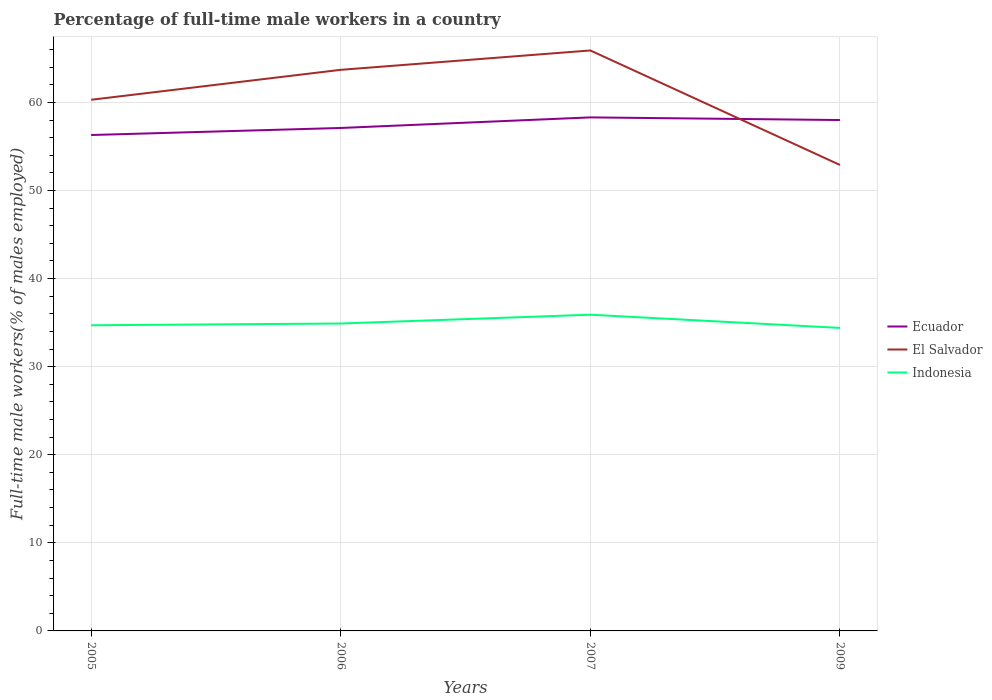How many different coloured lines are there?
Your answer should be compact. 3. Across all years, what is the maximum percentage of full-time male workers in Indonesia?
Offer a very short reply. 34.4. What is the total percentage of full-time male workers in Ecuador in the graph?
Your answer should be very brief. -0.9. What is the difference between the highest and the lowest percentage of full-time male workers in Ecuador?
Ensure brevity in your answer.  2. How many years are there in the graph?
Provide a succinct answer. 4. What is the difference between two consecutive major ticks on the Y-axis?
Your answer should be very brief. 10. Does the graph contain any zero values?
Keep it short and to the point. No. How many legend labels are there?
Provide a short and direct response. 3. How are the legend labels stacked?
Give a very brief answer. Vertical. What is the title of the graph?
Offer a terse response. Percentage of full-time male workers in a country. What is the label or title of the Y-axis?
Your answer should be very brief. Full-time male workers(% of males employed). What is the Full-time male workers(% of males employed) in Ecuador in 2005?
Provide a short and direct response. 56.3. What is the Full-time male workers(% of males employed) of El Salvador in 2005?
Your answer should be very brief. 60.3. What is the Full-time male workers(% of males employed) in Indonesia in 2005?
Keep it short and to the point. 34.7. What is the Full-time male workers(% of males employed) of Ecuador in 2006?
Provide a succinct answer. 57.1. What is the Full-time male workers(% of males employed) in El Salvador in 2006?
Your answer should be very brief. 63.7. What is the Full-time male workers(% of males employed) of Indonesia in 2006?
Provide a short and direct response. 34.9. What is the Full-time male workers(% of males employed) of Ecuador in 2007?
Your response must be concise. 58.3. What is the Full-time male workers(% of males employed) in El Salvador in 2007?
Offer a terse response. 65.9. What is the Full-time male workers(% of males employed) in Indonesia in 2007?
Your answer should be very brief. 35.9. What is the Full-time male workers(% of males employed) of El Salvador in 2009?
Make the answer very short. 52.9. What is the Full-time male workers(% of males employed) in Indonesia in 2009?
Keep it short and to the point. 34.4. Across all years, what is the maximum Full-time male workers(% of males employed) in Ecuador?
Provide a short and direct response. 58.3. Across all years, what is the maximum Full-time male workers(% of males employed) of El Salvador?
Give a very brief answer. 65.9. Across all years, what is the maximum Full-time male workers(% of males employed) in Indonesia?
Keep it short and to the point. 35.9. Across all years, what is the minimum Full-time male workers(% of males employed) of Ecuador?
Your answer should be very brief. 56.3. Across all years, what is the minimum Full-time male workers(% of males employed) of El Salvador?
Ensure brevity in your answer.  52.9. Across all years, what is the minimum Full-time male workers(% of males employed) of Indonesia?
Your answer should be very brief. 34.4. What is the total Full-time male workers(% of males employed) in Ecuador in the graph?
Ensure brevity in your answer.  229.7. What is the total Full-time male workers(% of males employed) in El Salvador in the graph?
Keep it short and to the point. 242.8. What is the total Full-time male workers(% of males employed) of Indonesia in the graph?
Make the answer very short. 139.9. What is the difference between the Full-time male workers(% of males employed) of Ecuador in 2005 and that in 2006?
Offer a very short reply. -0.8. What is the difference between the Full-time male workers(% of males employed) of El Salvador in 2005 and that in 2006?
Keep it short and to the point. -3.4. What is the difference between the Full-time male workers(% of males employed) in Ecuador in 2005 and that in 2007?
Your answer should be compact. -2. What is the difference between the Full-time male workers(% of males employed) of El Salvador in 2005 and that in 2007?
Ensure brevity in your answer.  -5.6. What is the difference between the Full-time male workers(% of males employed) in Indonesia in 2005 and that in 2007?
Your answer should be very brief. -1.2. What is the difference between the Full-time male workers(% of males employed) in Ecuador in 2005 and that in 2009?
Provide a succinct answer. -1.7. What is the difference between the Full-time male workers(% of males employed) of El Salvador in 2005 and that in 2009?
Provide a succinct answer. 7.4. What is the difference between the Full-time male workers(% of males employed) of El Salvador in 2006 and that in 2007?
Provide a short and direct response. -2.2. What is the difference between the Full-time male workers(% of males employed) of Indonesia in 2006 and that in 2007?
Give a very brief answer. -1. What is the difference between the Full-time male workers(% of males employed) of Ecuador in 2006 and that in 2009?
Provide a short and direct response. -0.9. What is the difference between the Full-time male workers(% of males employed) in El Salvador in 2006 and that in 2009?
Provide a succinct answer. 10.8. What is the difference between the Full-time male workers(% of males employed) of Indonesia in 2006 and that in 2009?
Give a very brief answer. 0.5. What is the difference between the Full-time male workers(% of males employed) in Ecuador in 2007 and that in 2009?
Your answer should be very brief. 0.3. What is the difference between the Full-time male workers(% of males employed) of El Salvador in 2007 and that in 2009?
Offer a terse response. 13. What is the difference between the Full-time male workers(% of males employed) in Indonesia in 2007 and that in 2009?
Provide a succinct answer. 1.5. What is the difference between the Full-time male workers(% of males employed) in Ecuador in 2005 and the Full-time male workers(% of males employed) in El Salvador in 2006?
Ensure brevity in your answer.  -7.4. What is the difference between the Full-time male workers(% of males employed) of Ecuador in 2005 and the Full-time male workers(% of males employed) of Indonesia in 2006?
Make the answer very short. 21.4. What is the difference between the Full-time male workers(% of males employed) in El Salvador in 2005 and the Full-time male workers(% of males employed) in Indonesia in 2006?
Your answer should be very brief. 25.4. What is the difference between the Full-time male workers(% of males employed) of Ecuador in 2005 and the Full-time male workers(% of males employed) of Indonesia in 2007?
Offer a very short reply. 20.4. What is the difference between the Full-time male workers(% of males employed) of El Salvador in 2005 and the Full-time male workers(% of males employed) of Indonesia in 2007?
Offer a terse response. 24.4. What is the difference between the Full-time male workers(% of males employed) in Ecuador in 2005 and the Full-time male workers(% of males employed) in El Salvador in 2009?
Provide a succinct answer. 3.4. What is the difference between the Full-time male workers(% of males employed) of Ecuador in 2005 and the Full-time male workers(% of males employed) of Indonesia in 2009?
Your answer should be very brief. 21.9. What is the difference between the Full-time male workers(% of males employed) in El Salvador in 2005 and the Full-time male workers(% of males employed) in Indonesia in 2009?
Ensure brevity in your answer.  25.9. What is the difference between the Full-time male workers(% of males employed) of Ecuador in 2006 and the Full-time male workers(% of males employed) of El Salvador in 2007?
Your answer should be compact. -8.8. What is the difference between the Full-time male workers(% of males employed) in Ecuador in 2006 and the Full-time male workers(% of males employed) in Indonesia in 2007?
Offer a very short reply. 21.2. What is the difference between the Full-time male workers(% of males employed) in El Salvador in 2006 and the Full-time male workers(% of males employed) in Indonesia in 2007?
Your response must be concise. 27.8. What is the difference between the Full-time male workers(% of males employed) of Ecuador in 2006 and the Full-time male workers(% of males employed) of El Salvador in 2009?
Provide a succinct answer. 4.2. What is the difference between the Full-time male workers(% of males employed) of Ecuador in 2006 and the Full-time male workers(% of males employed) of Indonesia in 2009?
Offer a very short reply. 22.7. What is the difference between the Full-time male workers(% of males employed) in El Salvador in 2006 and the Full-time male workers(% of males employed) in Indonesia in 2009?
Your response must be concise. 29.3. What is the difference between the Full-time male workers(% of males employed) in Ecuador in 2007 and the Full-time male workers(% of males employed) in El Salvador in 2009?
Ensure brevity in your answer.  5.4. What is the difference between the Full-time male workers(% of males employed) of Ecuador in 2007 and the Full-time male workers(% of males employed) of Indonesia in 2009?
Offer a very short reply. 23.9. What is the difference between the Full-time male workers(% of males employed) in El Salvador in 2007 and the Full-time male workers(% of males employed) in Indonesia in 2009?
Your response must be concise. 31.5. What is the average Full-time male workers(% of males employed) of Ecuador per year?
Your answer should be compact. 57.42. What is the average Full-time male workers(% of males employed) of El Salvador per year?
Ensure brevity in your answer.  60.7. What is the average Full-time male workers(% of males employed) of Indonesia per year?
Keep it short and to the point. 34.98. In the year 2005, what is the difference between the Full-time male workers(% of males employed) in Ecuador and Full-time male workers(% of males employed) in El Salvador?
Offer a terse response. -4. In the year 2005, what is the difference between the Full-time male workers(% of males employed) of Ecuador and Full-time male workers(% of males employed) of Indonesia?
Keep it short and to the point. 21.6. In the year 2005, what is the difference between the Full-time male workers(% of males employed) in El Salvador and Full-time male workers(% of males employed) in Indonesia?
Keep it short and to the point. 25.6. In the year 2006, what is the difference between the Full-time male workers(% of males employed) in Ecuador and Full-time male workers(% of males employed) in Indonesia?
Ensure brevity in your answer.  22.2. In the year 2006, what is the difference between the Full-time male workers(% of males employed) of El Salvador and Full-time male workers(% of males employed) of Indonesia?
Provide a short and direct response. 28.8. In the year 2007, what is the difference between the Full-time male workers(% of males employed) of Ecuador and Full-time male workers(% of males employed) of Indonesia?
Offer a very short reply. 22.4. In the year 2007, what is the difference between the Full-time male workers(% of males employed) in El Salvador and Full-time male workers(% of males employed) in Indonesia?
Your answer should be compact. 30. In the year 2009, what is the difference between the Full-time male workers(% of males employed) in Ecuador and Full-time male workers(% of males employed) in El Salvador?
Give a very brief answer. 5.1. In the year 2009, what is the difference between the Full-time male workers(% of males employed) in Ecuador and Full-time male workers(% of males employed) in Indonesia?
Provide a succinct answer. 23.6. In the year 2009, what is the difference between the Full-time male workers(% of males employed) in El Salvador and Full-time male workers(% of males employed) in Indonesia?
Make the answer very short. 18.5. What is the ratio of the Full-time male workers(% of males employed) in Ecuador in 2005 to that in 2006?
Keep it short and to the point. 0.99. What is the ratio of the Full-time male workers(% of males employed) of El Salvador in 2005 to that in 2006?
Give a very brief answer. 0.95. What is the ratio of the Full-time male workers(% of males employed) in Indonesia in 2005 to that in 2006?
Make the answer very short. 0.99. What is the ratio of the Full-time male workers(% of males employed) in Ecuador in 2005 to that in 2007?
Provide a succinct answer. 0.97. What is the ratio of the Full-time male workers(% of males employed) of El Salvador in 2005 to that in 2007?
Your answer should be very brief. 0.92. What is the ratio of the Full-time male workers(% of males employed) in Indonesia in 2005 to that in 2007?
Make the answer very short. 0.97. What is the ratio of the Full-time male workers(% of males employed) in Ecuador in 2005 to that in 2009?
Provide a short and direct response. 0.97. What is the ratio of the Full-time male workers(% of males employed) of El Salvador in 2005 to that in 2009?
Make the answer very short. 1.14. What is the ratio of the Full-time male workers(% of males employed) of Indonesia in 2005 to that in 2009?
Offer a terse response. 1.01. What is the ratio of the Full-time male workers(% of males employed) in Ecuador in 2006 to that in 2007?
Ensure brevity in your answer.  0.98. What is the ratio of the Full-time male workers(% of males employed) of El Salvador in 2006 to that in 2007?
Your answer should be compact. 0.97. What is the ratio of the Full-time male workers(% of males employed) in Indonesia in 2006 to that in 2007?
Ensure brevity in your answer.  0.97. What is the ratio of the Full-time male workers(% of males employed) of Ecuador in 2006 to that in 2009?
Provide a short and direct response. 0.98. What is the ratio of the Full-time male workers(% of males employed) of El Salvador in 2006 to that in 2009?
Your answer should be very brief. 1.2. What is the ratio of the Full-time male workers(% of males employed) in Indonesia in 2006 to that in 2009?
Ensure brevity in your answer.  1.01. What is the ratio of the Full-time male workers(% of males employed) of Ecuador in 2007 to that in 2009?
Keep it short and to the point. 1.01. What is the ratio of the Full-time male workers(% of males employed) of El Salvador in 2007 to that in 2009?
Provide a succinct answer. 1.25. What is the ratio of the Full-time male workers(% of males employed) in Indonesia in 2007 to that in 2009?
Keep it short and to the point. 1.04. What is the difference between the highest and the second highest Full-time male workers(% of males employed) in El Salvador?
Provide a short and direct response. 2.2. What is the difference between the highest and the second highest Full-time male workers(% of males employed) in Indonesia?
Provide a short and direct response. 1. What is the difference between the highest and the lowest Full-time male workers(% of males employed) of Indonesia?
Make the answer very short. 1.5. 